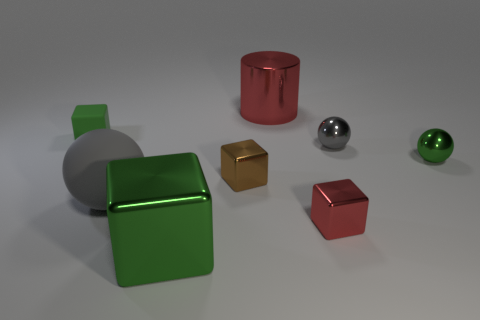Subtract all cyan cubes. Subtract all green cylinders. How many cubes are left? 4 Add 2 brown rubber things. How many objects exist? 10 Subtract all cylinders. How many objects are left? 7 Add 8 big cubes. How many big cubes exist? 9 Subtract 0 purple cylinders. How many objects are left? 8 Subtract all tiny gray rubber balls. Subtract all big green shiny cubes. How many objects are left? 7 Add 7 gray rubber things. How many gray rubber things are left? 8 